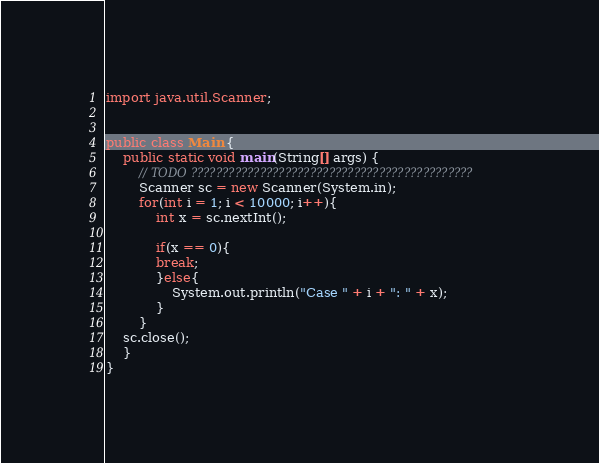<code> <loc_0><loc_0><loc_500><loc_500><_Java_>import java.util.Scanner;


public class Main {
	public static void main(String[] args) {
		// TODO ?????????????????????????????????????????????
		Scanner sc = new Scanner(System.in);
		for(int i = 1; i < 10000; i++){
			int x = sc.nextInt();

			if(x == 0){
			break;
			}else{
				System.out.println("Case " + i + ": " + x);
			}				
		}
	sc.close();
	}
}</code> 